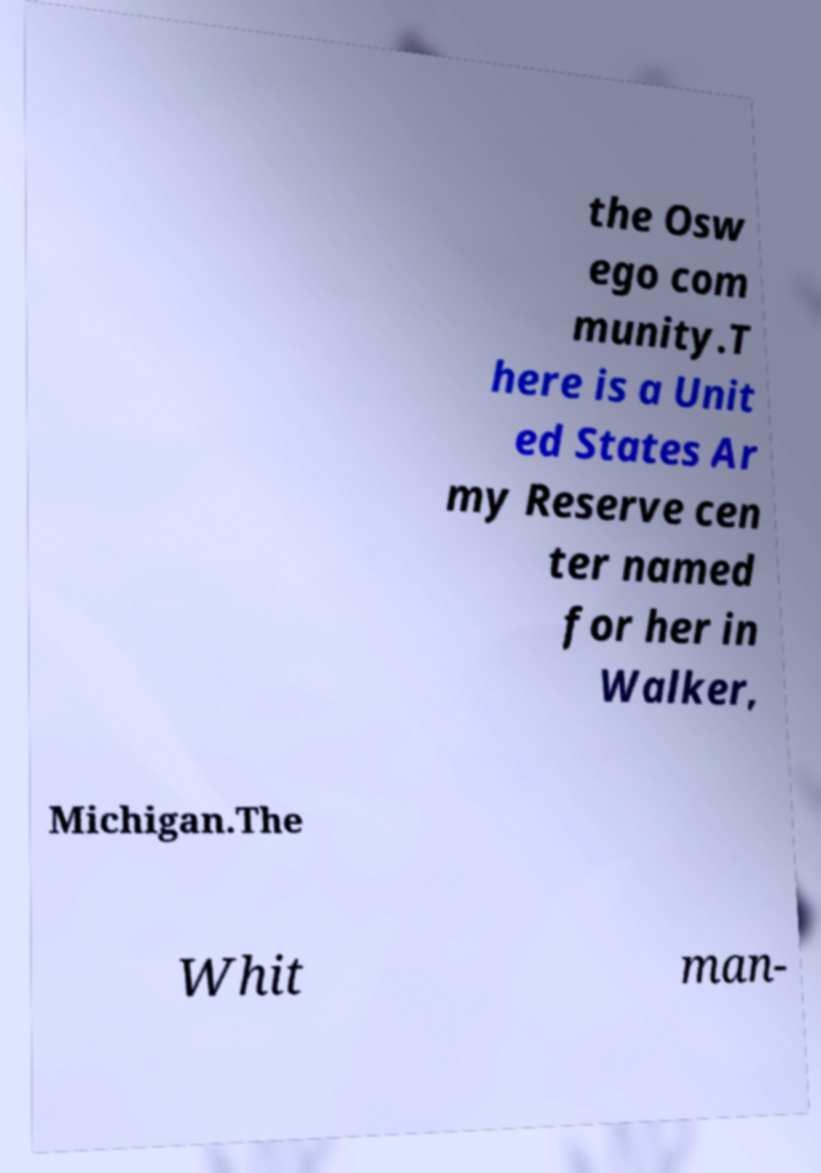For documentation purposes, I need the text within this image transcribed. Could you provide that? the Osw ego com munity.T here is a Unit ed States Ar my Reserve cen ter named for her in Walker, Michigan.The Whit man- 